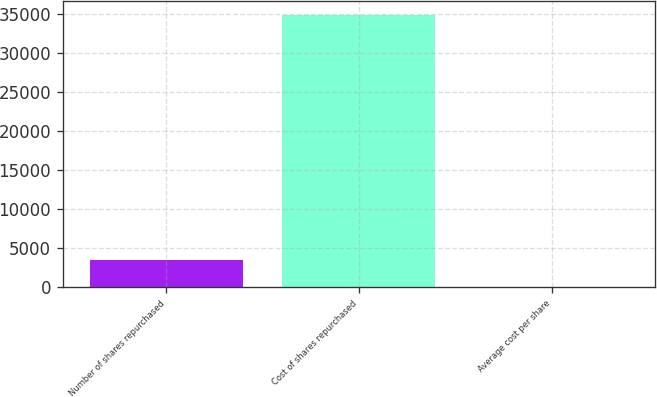Convert chart to OTSL. <chart><loc_0><loc_0><loc_500><loc_500><bar_chart><fcel>Number of shares repurchased<fcel>Cost of shares repurchased<fcel>Average cost per share<nl><fcel>3564.36<fcel>34811<fcel>92.51<nl></chart> 